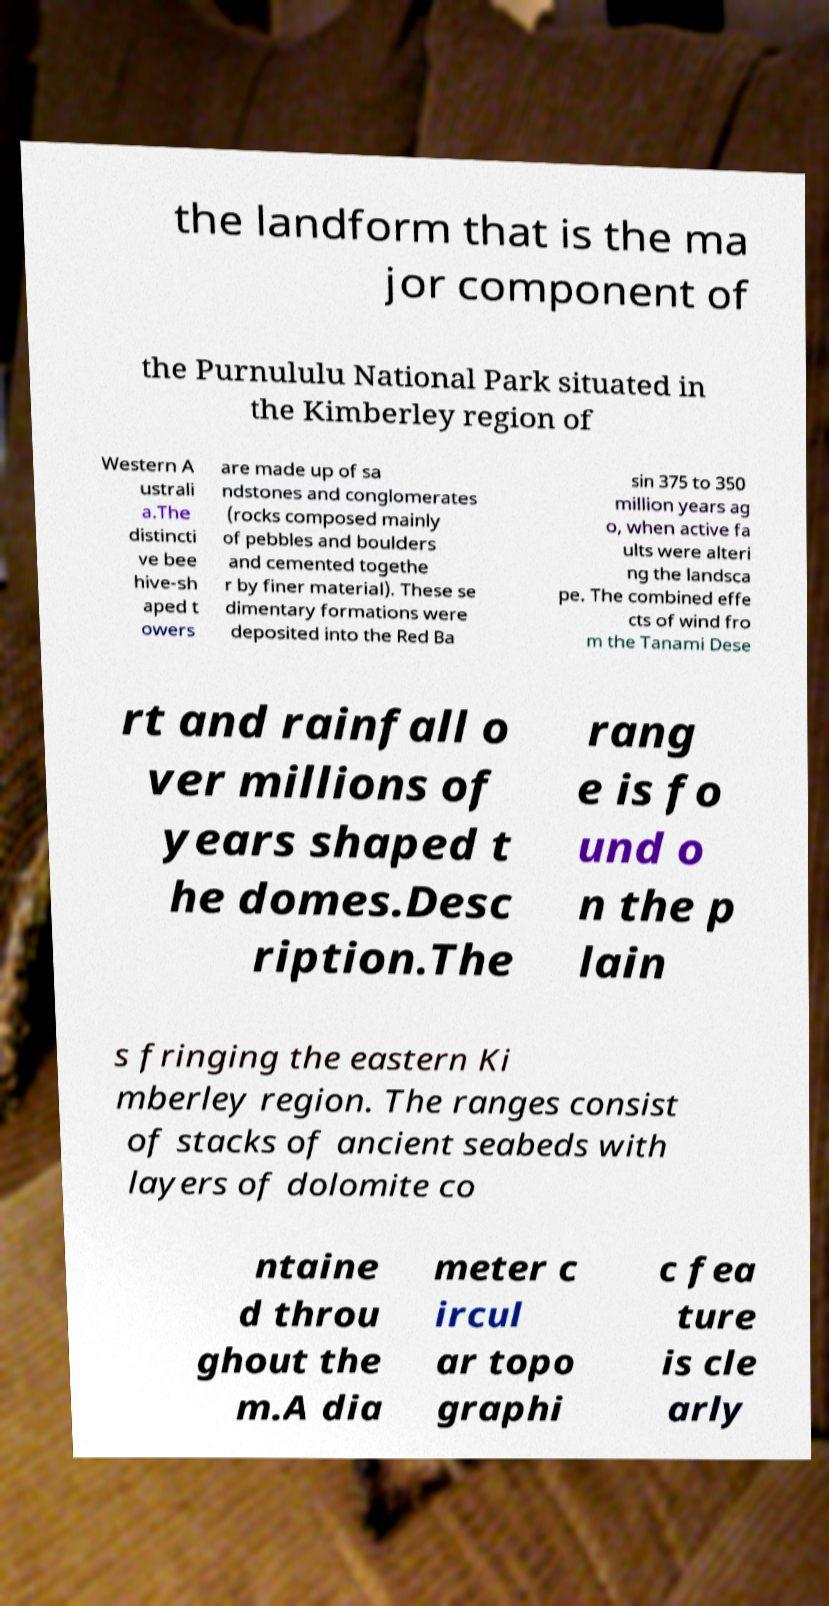For documentation purposes, I need the text within this image transcribed. Could you provide that? the landform that is the ma jor component of the Purnululu National Park situated in the Kimberley region of Western A ustrali a.The distincti ve bee hive-sh aped t owers are made up of sa ndstones and conglomerates (rocks composed mainly of pebbles and boulders and cemented togethe r by finer material). These se dimentary formations were deposited into the Red Ba sin 375 to 350 million years ag o, when active fa ults were alteri ng the landsca pe. The combined effe cts of wind fro m the Tanami Dese rt and rainfall o ver millions of years shaped t he domes.Desc ription.The rang e is fo und o n the p lain s fringing the eastern Ki mberley region. The ranges consist of stacks of ancient seabeds with layers of dolomite co ntaine d throu ghout the m.A dia meter c ircul ar topo graphi c fea ture is cle arly 